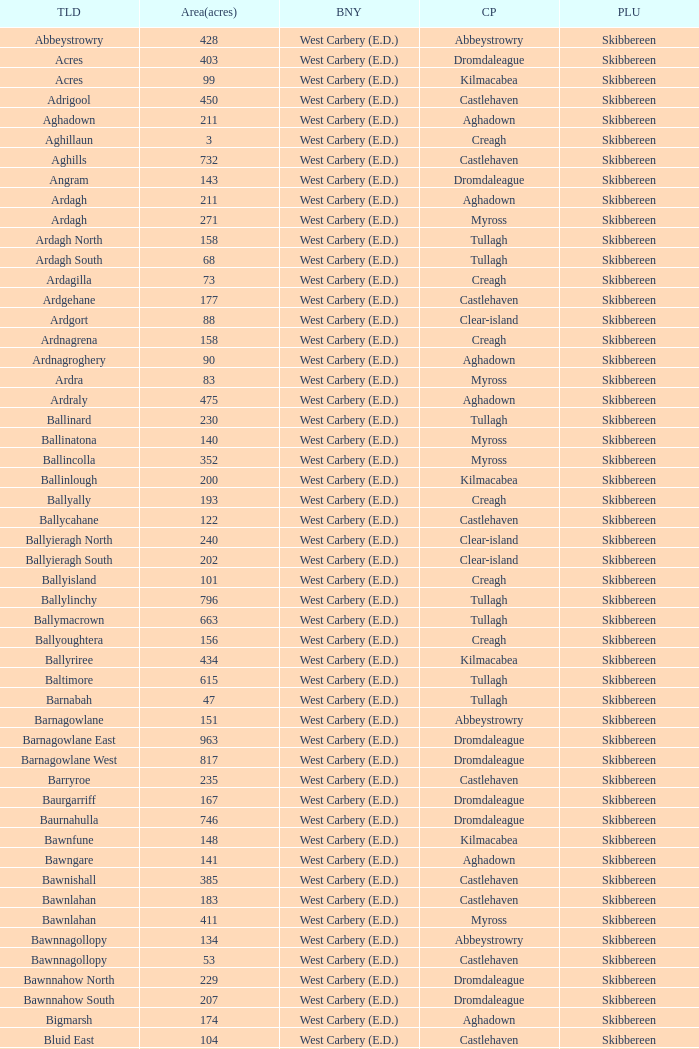What are the Poor Law Unions when the area (in acres) is 142? Skibbereen. 